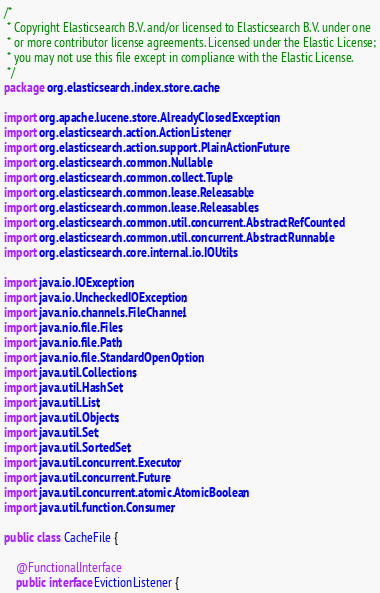Convert code to text. <code><loc_0><loc_0><loc_500><loc_500><_Java_>/*
 * Copyright Elasticsearch B.V. and/or licensed to Elasticsearch B.V. under one
 * or more contributor license agreements. Licensed under the Elastic License;
 * you may not use this file except in compliance with the Elastic License.
 */
package org.elasticsearch.index.store.cache;

import org.apache.lucene.store.AlreadyClosedException;
import org.elasticsearch.action.ActionListener;
import org.elasticsearch.action.support.PlainActionFuture;
import org.elasticsearch.common.Nullable;
import org.elasticsearch.common.collect.Tuple;
import org.elasticsearch.common.lease.Releasable;
import org.elasticsearch.common.lease.Releasables;
import org.elasticsearch.common.util.concurrent.AbstractRefCounted;
import org.elasticsearch.common.util.concurrent.AbstractRunnable;
import org.elasticsearch.core.internal.io.IOUtils;

import java.io.IOException;
import java.io.UncheckedIOException;
import java.nio.channels.FileChannel;
import java.nio.file.Files;
import java.nio.file.Path;
import java.nio.file.StandardOpenOption;
import java.util.Collections;
import java.util.HashSet;
import java.util.List;
import java.util.Objects;
import java.util.Set;
import java.util.SortedSet;
import java.util.concurrent.Executor;
import java.util.concurrent.Future;
import java.util.concurrent.atomic.AtomicBoolean;
import java.util.function.Consumer;

public class CacheFile {

    @FunctionalInterface
    public interface EvictionListener {</code> 